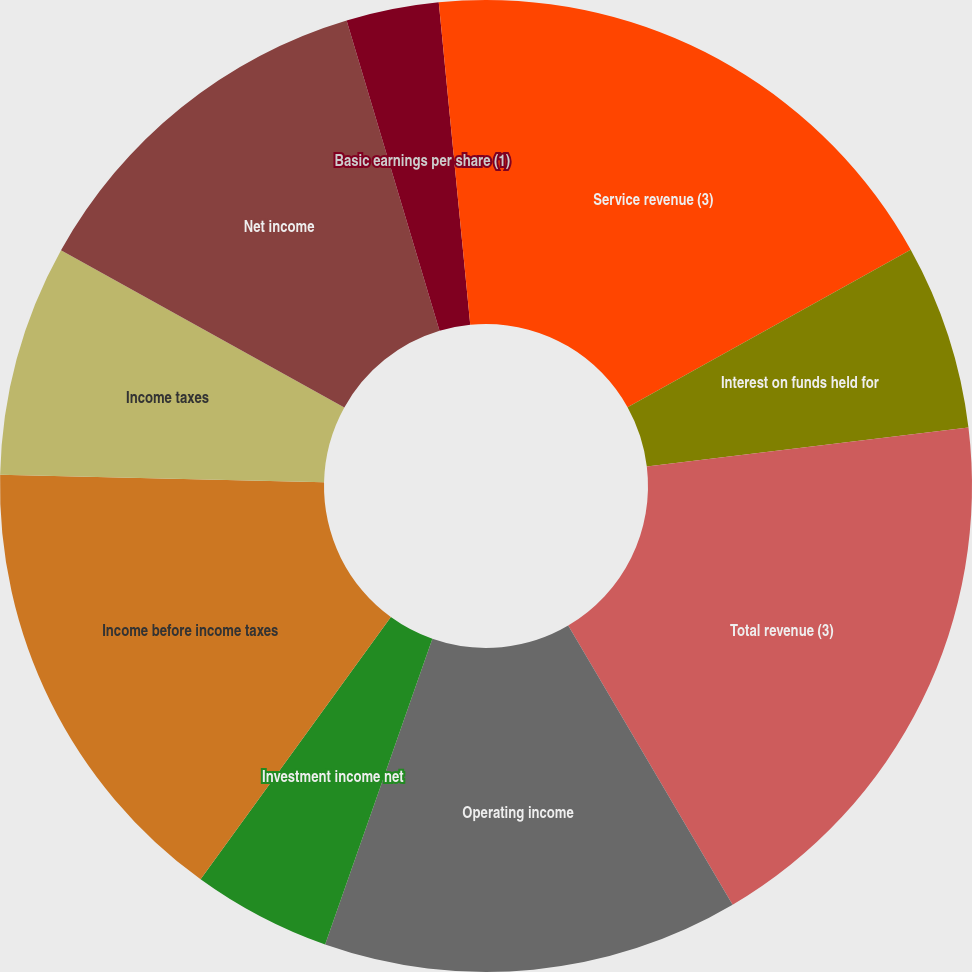<chart> <loc_0><loc_0><loc_500><loc_500><pie_chart><fcel>Service revenue (3)<fcel>Interest on funds held for<fcel>Total revenue (3)<fcel>Operating income<fcel>Investment income net<fcel>Income before income taxes<fcel>Income taxes<fcel>Net income<fcel>Basic earnings per share (1)<fcel>Diluted earnings per share (1)<nl><fcel>16.92%<fcel>6.16%<fcel>18.45%<fcel>13.84%<fcel>4.62%<fcel>15.38%<fcel>7.69%<fcel>12.31%<fcel>3.08%<fcel>1.55%<nl></chart> 